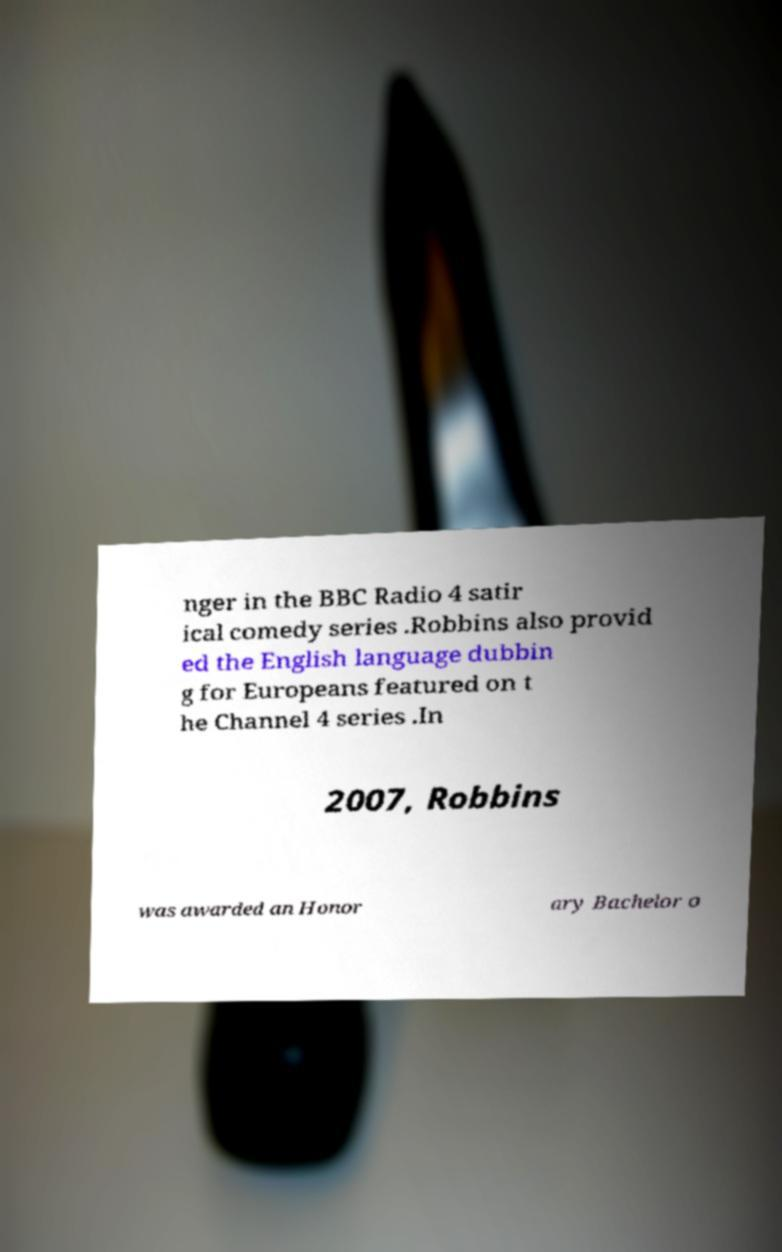There's text embedded in this image that I need extracted. Can you transcribe it verbatim? nger in the BBC Radio 4 satir ical comedy series .Robbins also provid ed the English language dubbin g for Europeans featured on t he Channel 4 series .In 2007, Robbins was awarded an Honor ary Bachelor o 